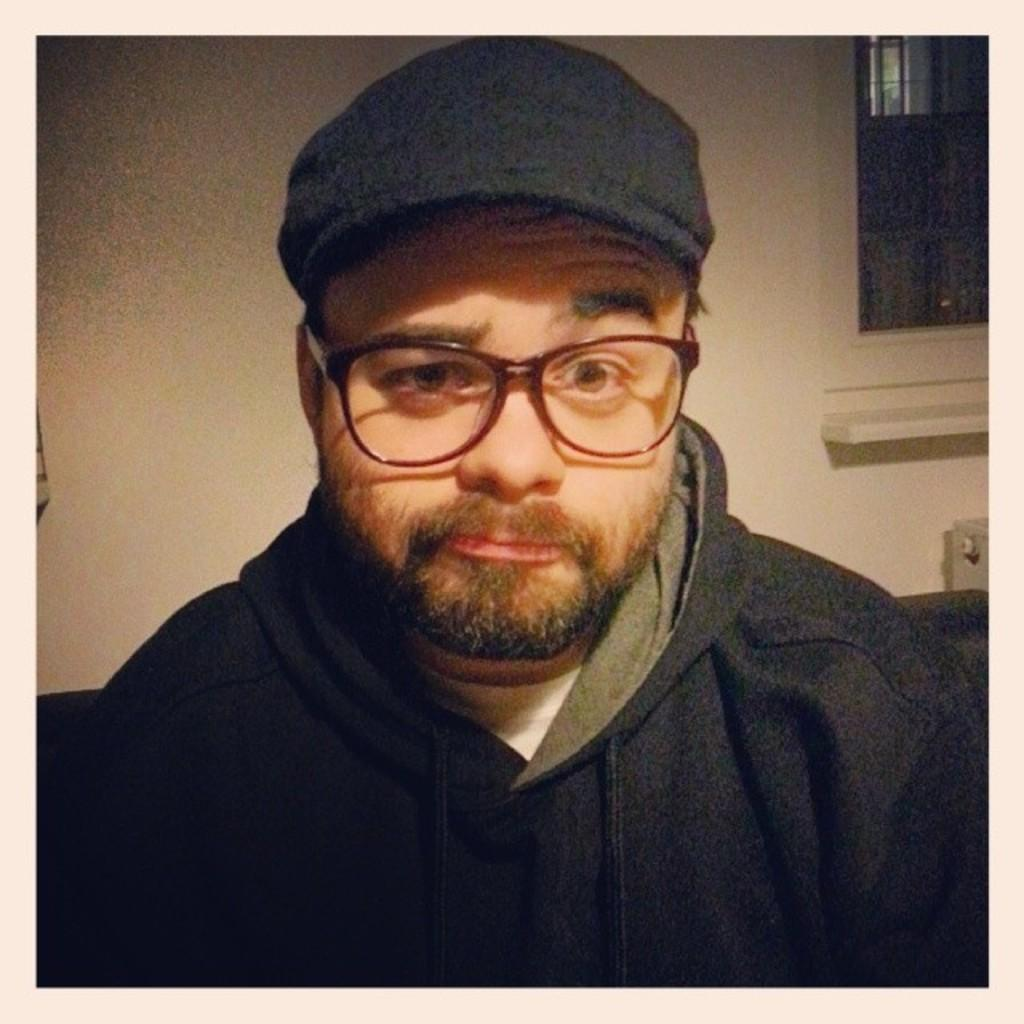Where was the image taken? The image is taken indoors. What can be seen in the background of the image? There is a wall with a window in the background. Who is the main subject in the image? There is a man in the middle of the image. What is the man wearing on his head? The man is wearing a cap. What type of clothing is the man wearing on his upper body? The man is wearing a sweatshirt. What accessory is the man wearing on his face? The man is wearing spectacles. What type of sea creature can be seen swimming in the image? There is no sea creature present in the image; it is taken indoors and features a man wearing a cap, sweatshirt, and spectacles. 